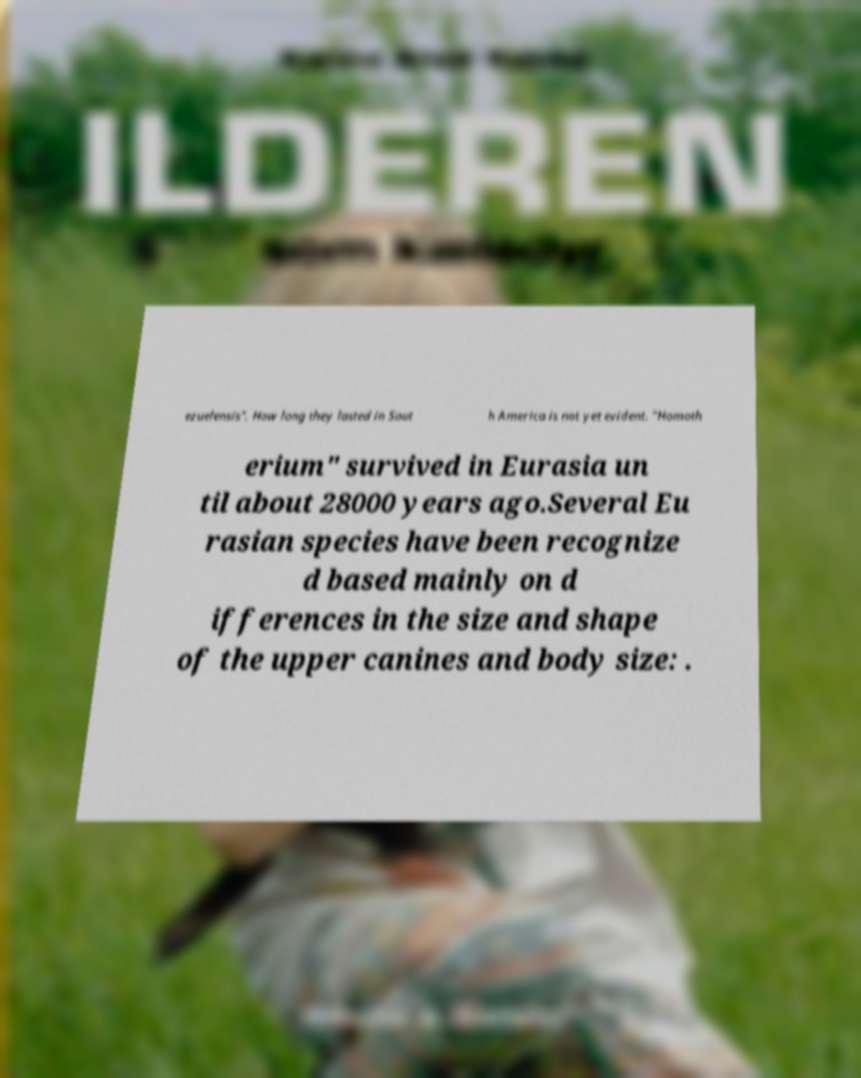Can you accurately transcribe the text from the provided image for me? ezuelensis". How long they lasted in Sout h America is not yet evident. "Homoth erium" survived in Eurasia un til about 28000 years ago.Several Eu rasian species have been recognize d based mainly on d ifferences in the size and shape of the upper canines and body size: . 